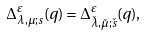<formula> <loc_0><loc_0><loc_500><loc_500>\Delta ^ { \varepsilon } _ { \lambda , \mu ; s } ( q ) = \Delta ^ { \varepsilon } _ { \check { \lambda } , \check { \mu } ; \check { s } } ( q ) ,</formula> 